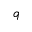Convert formula to latex. <formula><loc_0><loc_0><loc_500><loc_500>q</formula> 